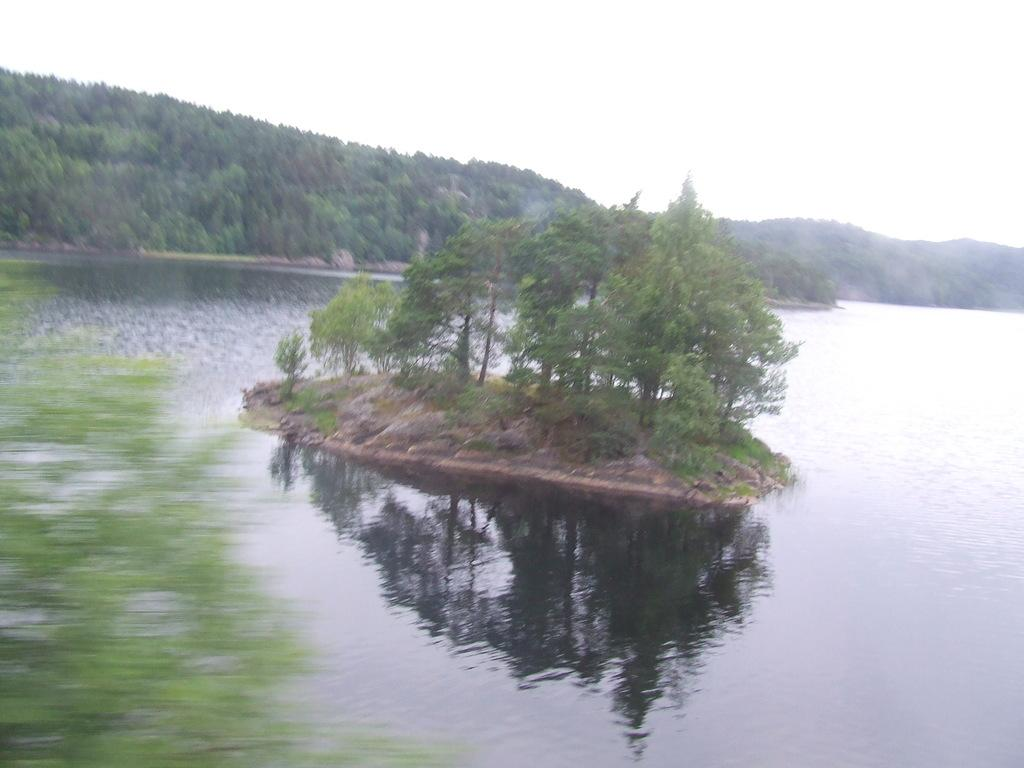What is visible in the image? Water, trees, and a mountain are visible in the image. What can be seen in the background of the image? The sky is visible in the background of the image. What type of natural landscape is depicted in the image? The image features a mountain and trees, indicating a mountainous or forested landscape. What type of jeans is the mountain wearing in the image? There are no jeans present in the image, as the mountain is a natural formation and not a person wearing clothing. 